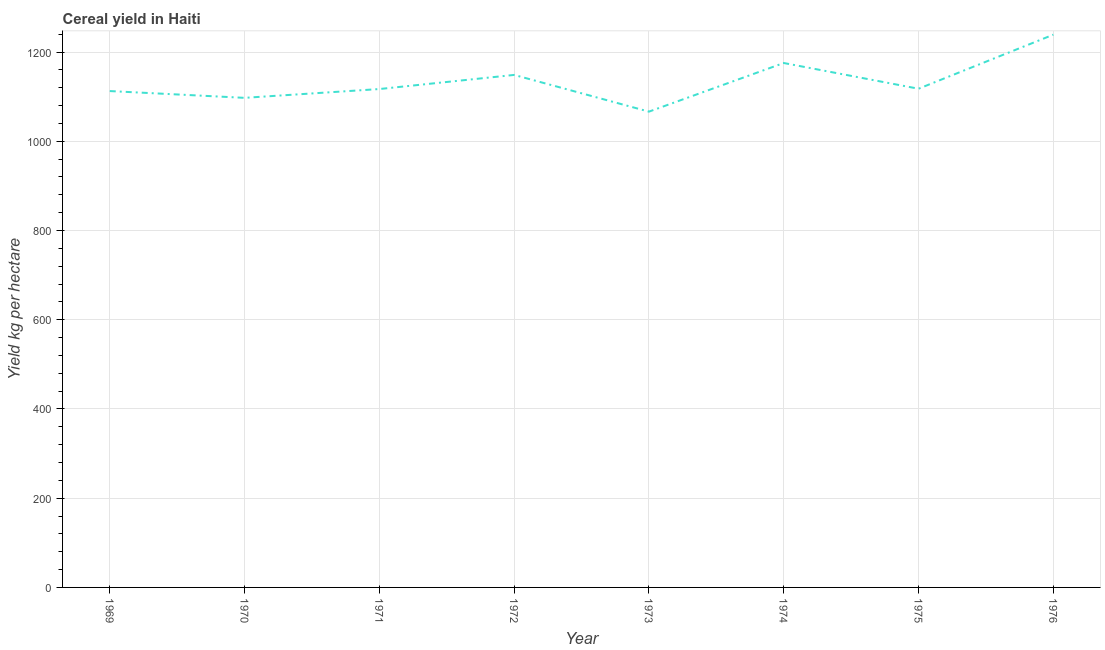What is the cereal yield in 1973?
Offer a terse response. 1066.38. Across all years, what is the maximum cereal yield?
Provide a succinct answer. 1238.89. Across all years, what is the minimum cereal yield?
Your answer should be compact. 1066.38. In which year was the cereal yield maximum?
Your answer should be compact. 1976. What is the sum of the cereal yield?
Your answer should be very brief. 9073.91. What is the difference between the cereal yield in 1972 and 1975?
Make the answer very short. 30.95. What is the average cereal yield per year?
Provide a succinct answer. 1134.24. What is the median cereal yield?
Keep it short and to the point. 1117.38. In how many years, is the cereal yield greater than 1200 kg per hectare?
Offer a very short reply. 1. What is the ratio of the cereal yield in 1974 to that in 1975?
Your answer should be compact. 1.05. Is the difference between the cereal yield in 1969 and 1973 greater than the difference between any two years?
Ensure brevity in your answer.  No. What is the difference between the highest and the second highest cereal yield?
Provide a succinct answer. 63.5. What is the difference between the highest and the lowest cereal yield?
Your answer should be very brief. 172.51. How many lines are there?
Offer a very short reply. 1. How many years are there in the graph?
Provide a short and direct response. 8. What is the difference between two consecutive major ticks on the Y-axis?
Your answer should be compact. 200. Does the graph contain any zero values?
Provide a short and direct response. No. What is the title of the graph?
Ensure brevity in your answer.  Cereal yield in Haiti. What is the label or title of the X-axis?
Provide a succinct answer. Year. What is the label or title of the Y-axis?
Offer a terse response. Yield kg per hectare. What is the Yield kg per hectare of 1969?
Your answer should be compact. 1112.5. What is the Yield kg per hectare in 1970?
Make the answer very short. 1097.31. What is the Yield kg per hectare in 1971?
Provide a short and direct response. 1117.04. What is the Yield kg per hectare in 1972?
Offer a terse response. 1148.68. What is the Yield kg per hectare of 1973?
Provide a short and direct response. 1066.38. What is the Yield kg per hectare in 1974?
Ensure brevity in your answer.  1175.38. What is the Yield kg per hectare in 1975?
Your answer should be very brief. 1117.72. What is the Yield kg per hectare in 1976?
Keep it short and to the point. 1238.89. What is the difference between the Yield kg per hectare in 1969 and 1970?
Your response must be concise. 15.19. What is the difference between the Yield kg per hectare in 1969 and 1971?
Your response must be concise. -4.54. What is the difference between the Yield kg per hectare in 1969 and 1972?
Provide a succinct answer. -36.18. What is the difference between the Yield kg per hectare in 1969 and 1973?
Your answer should be compact. 46.12. What is the difference between the Yield kg per hectare in 1969 and 1974?
Keep it short and to the point. -62.88. What is the difference between the Yield kg per hectare in 1969 and 1975?
Keep it short and to the point. -5.22. What is the difference between the Yield kg per hectare in 1969 and 1976?
Make the answer very short. -126.39. What is the difference between the Yield kg per hectare in 1970 and 1971?
Your answer should be very brief. -19.73. What is the difference between the Yield kg per hectare in 1970 and 1972?
Offer a terse response. -51.37. What is the difference between the Yield kg per hectare in 1970 and 1973?
Your answer should be compact. 30.93. What is the difference between the Yield kg per hectare in 1970 and 1974?
Keep it short and to the point. -78.08. What is the difference between the Yield kg per hectare in 1970 and 1975?
Your answer should be compact. -20.42. What is the difference between the Yield kg per hectare in 1970 and 1976?
Offer a very short reply. -141.58. What is the difference between the Yield kg per hectare in 1971 and 1972?
Your answer should be very brief. -31.63. What is the difference between the Yield kg per hectare in 1971 and 1973?
Provide a short and direct response. 50.66. What is the difference between the Yield kg per hectare in 1971 and 1974?
Ensure brevity in your answer.  -58.34. What is the difference between the Yield kg per hectare in 1971 and 1975?
Offer a terse response. -0.68. What is the difference between the Yield kg per hectare in 1971 and 1976?
Ensure brevity in your answer.  -121.85. What is the difference between the Yield kg per hectare in 1972 and 1973?
Your answer should be compact. 82.3. What is the difference between the Yield kg per hectare in 1972 and 1974?
Keep it short and to the point. -26.71. What is the difference between the Yield kg per hectare in 1972 and 1975?
Offer a very short reply. 30.95. What is the difference between the Yield kg per hectare in 1972 and 1976?
Make the answer very short. -90.21. What is the difference between the Yield kg per hectare in 1973 and 1974?
Your answer should be compact. -109. What is the difference between the Yield kg per hectare in 1973 and 1975?
Provide a succinct answer. -51.34. What is the difference between the Yield kg per hectare in 1973 and 1976?
Provide a succinct answer. -172.51. What is the difference between the Yield kg per hectare in 1974 and 1975?
Provide a short and direct response. 57.66. What is the difference between the Yield kg per hectare in 1974 and 1976?
Provide a succinct answer. -63.5. What is the difference between the Yield kg per hectare in 1975 and 1976?
Keep it short and to the point. -121.16. What is the ratio of the Yield kg per hectare in 1969 to that in 1970?
Make the answer very short. 1.01. What is the ratio of the Yield kg per hectare in 1969 to that in 1971?
Keep it short and to the point. 1. What is the ratio of the Yield kg per hectare in 1969 to that in 1972?
Your answer should be compact. 0.97. What is the ratio of the Yield kg per hectare in 1969 to that in 1973?
Offer a terse response. 1.04. What is the ratio of the Yield kg per hectare in 1969 to that in 1974?
Your answer should be very brief. 0.95. What is the ratio of the Yield kg per hectare in 1969 to that in 1976?
Your answer should be very brief. 0.9. What is the ratio of the Yield kg per hectare in 1970 to that in 1972?
Give a very brief answer. 0.95. What is the ratio of the Yield kg per hectare in 1970 to that in 1974?
Offer a very short reply. 0.93. What is the ratio of the Yield kg per hectare in 1970 to that in 1976?
Your answer should be very brief. 0.89. What is the ratio of the Yield kg per hectare in 1971 to that in 1973?
Make the answer very short. 1.05. What is the ratio of the Yield kg per hectare in 1971 to that in 1974?
Offer a very short reply. 0.95. What is the ratio of the Yield kg per hectare in 1971 to that in 1975?
Your answer should be compact. 1. What is the ratio of the Yield kg per hectare in 1971 to that in 1976?
Your answer should be compact. 0.9. What is the ratio of the Yield kg per hectare in 1972 to that in 1973?
Keep it short and to the point. 1.08. What is the ratio of the Yield kg per hectare in 1972 to that in 1975?
Your answer should be compact. 1.03. What is the ratio of the Yield kg per hectare in 1972 to that in 1976?
Ensure brevity in your answer.  0.93. What is the ratio of the Yield kg per hectare in 1973 to that in 1974?
Your response must be concise. 0.91. What is the ratio of the Yield kg per hectare in 1973 to that in 1975?
Your answer should be very brief. 0.95. What is the ratio of the Yield kg per hectare in 1973 to that in 1976?
Provide a short and direct response. 0.86. What is the ratio of the Yield kg per hectare in 1974 to that in 1975?
Your answer should be compact. 1.05. What is the ratio of the Yield kg per hectare in 1974 to that in 1976?
Keep it short and to the point. 0.95. What is the ratio of the Yield kg per hectare in 1975 to that in 1976?
Offer a terse response. 0.9. 